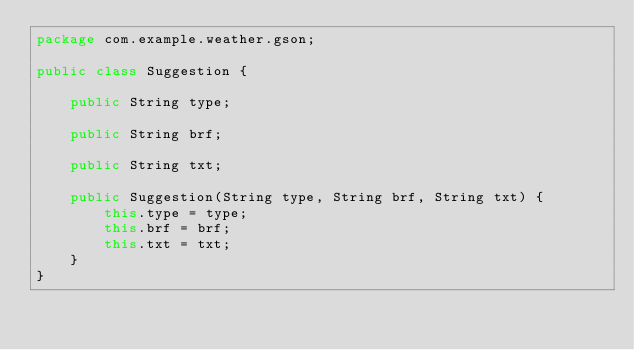<code> <loc_0><loc_0><loc_500><loc_500><_Java_>package com.example.weather.gson;

public class Suggestion {

    public String type;

    public String brf;

    public String txt;

    public Suggestion(String type, String brf, String txt) {
        this.type = type;
        this.brf = brf;
        this.txt = txt;
    }
}
</code> 